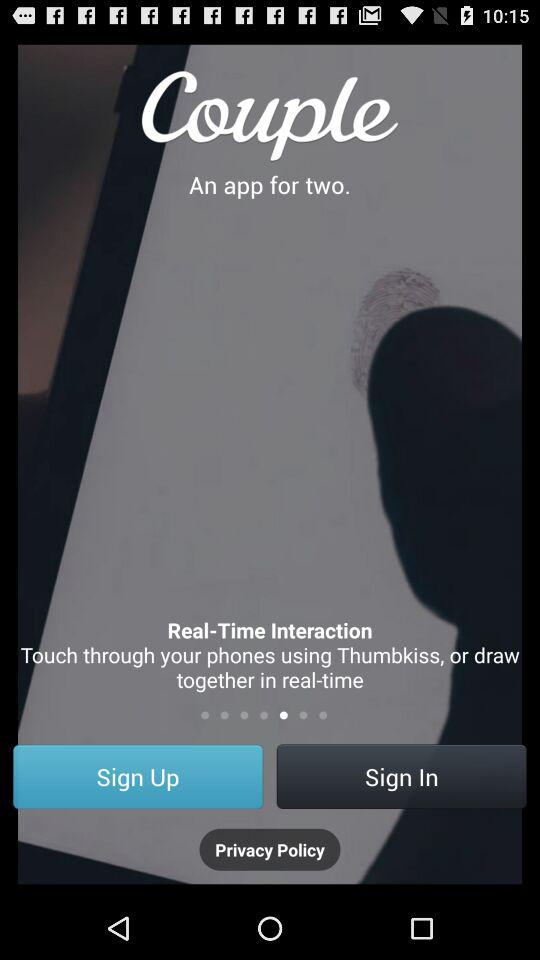What is the application name? The application name is "Couple". 